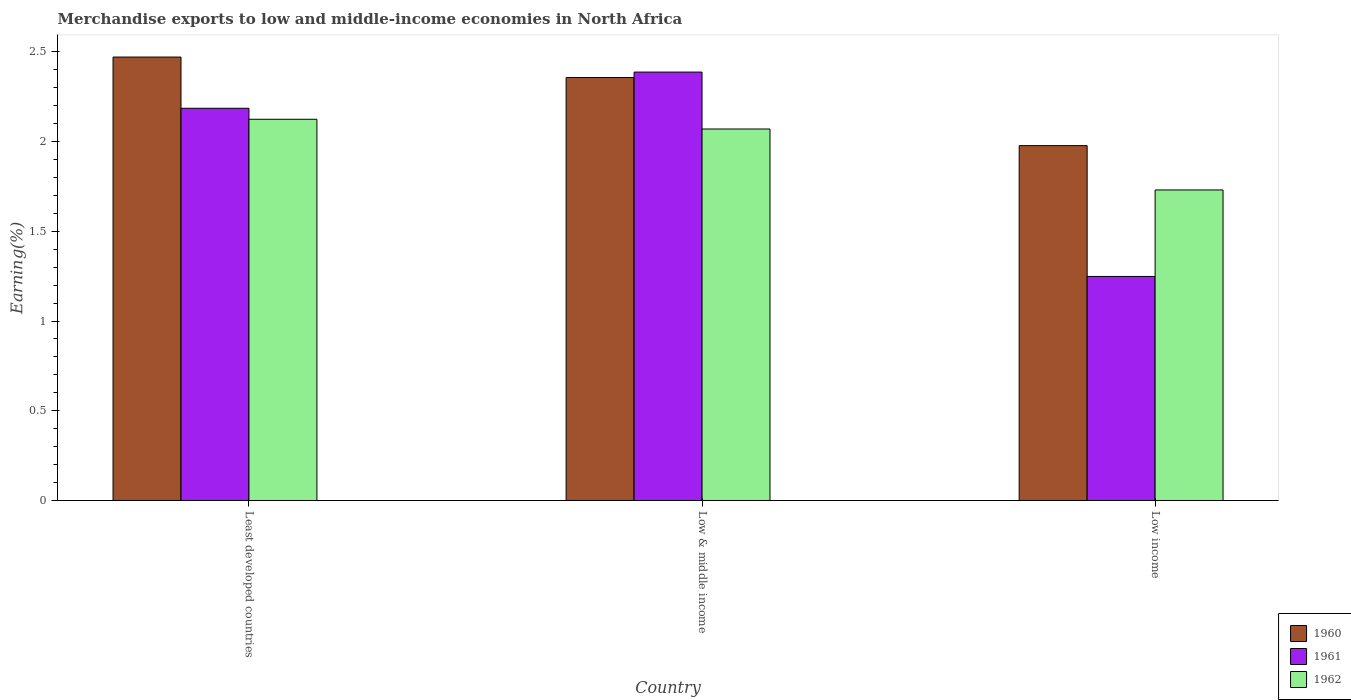How many groups of bars are there?
Your response must be concise. 3. How many bars are there on the 2nd tick from the left?
Keep it short and to the point. 3. How many bars are there on the 2nd tick from the right?
Provide a short and direct response. 3. What is the label of the 1st group of bars from the left?
Your response must be concise. Least developed countries. What is the percentage of amount earned from merchandise exports in 1961 in Low & middle income?
Offer a terse response. 2.39. Across all countries, what is the maximum percentage of amount earned from merchandise exports in 1962?
Make the answer very short. 2.12. Across all countries, what is the minimum percentage of amount earned from merchandise exports in 1962?
Make the answer very short. 1.73. What is the total percentage of amount earned from merchandise exports in 1961 in the graph?
Ensure brevity in your answer.  5.82. What is the difference between the percentage of amount earned from merchandise exports in 1960 in Least developed countries and that in Low income?
Provide a short and direct response. 0.49. What is the difference between the percentage of amount earned from merchandise exports in 1961 in Least developed countries and the percentage of amount earned from merchandise exports in 1960 in Low & middle income?
Make the answer very short. -0.17. What is the average percentage of amount earned from merchandise exports in 1960 per country?
Give a very brief answer. 2.27. What is the difference between the percentage of amount earned from merchandise exports of/in 1962 and percentage of amount earned from merchandise exports of/in 1960 in Low income?
Your response must be concise. -0.25. What is the ratio of the percentage of amount earned from merchandise exports in 1962 in Low & middle income to that in Low income?
Keep it short and to the point. 1.2. Is the percentage of amount earned from merchandise exports in 1961 in Least developed countries less than that in Low & middle income?
Your answer should be very brief. Yes. What is the difference between the highest and the second highest percentage of amount earned from merchandise exports in 1962?
Offer a very short reply. -0.39. What is the difference between the highest and the lowest percentage of amount earned from merchandise exports in 1960?
Your answer should be compact. 0.49. Is the sum of the percentage of amount earned from merchandise exports in 1962 in Least developed countries and Low & middle income greater than the maximum percentage of amount earned from merchandise exports in 1960 across all countries?
Your response must be concise. Yes. How many countries are there in the graph?
Provide a short and direct response. 3. What is the difference between two consecutive major ticks on the Y-axis?
Ensure brevity in your answer.  0.5. Are the values on the major ticks of Y-axis written in scientific E-notation?
Ensure brevity in your answer.  No. Does the graph contain any zero values?
Provide a short and direct response. No. What is the title of the graph?
Offer a very short reply. Merchandise exports to low and middle-income economies in North Africa. What is the label or title of the X-axis?
Your answer should be very brief. Country. What is the label or title of the Y-axis?
Your response must be concise. Earning(%). What is the Earning(%) in 1960 in Least developed countries?
Keep it short and to the point. 2.47. What is the Earning(%) of 1961 in Least developed countries?
Provide a short and direct response. 2.19. What is the Earning(%) of 1962 in Least developed countries?
Provide a short and direct response. 2.12. What is the Earning(%) of 1960 in Low & middle income?
Give a very brief answer. 2.36. What is the Earning(%) in 1961 in Low & middle income?
Ensure brevity in your answer.  2.39. What is the Earning(%) in 1962 in Low & middle income?
Offer a terse response. 2.07. What is the Earning(%) of 1960 in Low income?
Provide a short and direct response. 1.98. What is the Earning(%) of 1961 in Low income?
Offer a terse response. 1.25. What is the Earning(%) in 1962 in Low income?
Make the answer very short. 1.73. Across all countries, what is the maximum Earning(%) in 1960?
Provide a short and direct response. 2.47. Across all countries, what is the maximum Earning(%) in 1961?
Offer a terse response. 2.39. Across all countries, what is the maximum Earning(%) in 1962?
Your response must be concise. 2.12. Across all countries, what is the minimum Earning(%) of 1960?
Provide a short and direct response. 1.98. Across all countries, what is the minimum Earning(%) in 1961?
Your answer should be compact. 1.25. Across all countries, what is the minimum Earning(%) of 1962?
Your response must be concise. 1.73. What is the total Earning(%) in 1960 in the graph?
Make the answer very short. 6.8. What is the total Earning(%) of 1961 in the graph?
Offer a terse response. 5.82. What is the total Earning(%) of 1962 in the graph?
Provide a succinct answer. 5.92. What is the difference between the Earning(%) in 1960 in Least developed countries and that in Low & middle income?
Your answer should be very brief. 0.11. What is the difference between the Earning(%) in 1961 in Least developed countries and that in Low & middle income?
Make the answer very short. -0.2. What is the difference between the Earning(%) in 1962 in Least developed countries and that in Low & middle income?
Make the answer very short. 0.05. What is the difference between the Earning(%) in 1960 in Least developed countries and that in Low income?
Your response must be concise. 0.49. What is the difference between the Earning(%) in 1961 in Least developed countries and that in Low income?
Your response must be concise. 0.94. What is the difference between the Earning(%) of 1962 in Least developed countries and that in Low income?
Give a very brief answer. 0.39. What is the difference between the Earning(%) of 1960 in Low & middle income and that in Low income?
Provide a short and direct response. 0.38. What is the difference between the Earning(%) in 1961 in Low & middle income and that in Low income?
Ensure brevity in your answer.  1.14. What is the difference between the Earning(%) in 1962 in Low & middle income and that in Low income?
Offer a very short reply. 0.34. What is the difference between the Earning(%) of 1960 in Least developed countries and the Earning(%) of 1961 in Low & middle income?
Keep it short and to the point. 0.08. What is the difference between the Earning(%) of 1960 in Least developed countries and the Earning(%) of 1962 in Low & middle income?
Keep it short and to the point. 0.4. What is the difference between the Earning(%) of 1961 in Least developed countries and the Earning(%) of 1962 in Low & middle income?
Keep it short and to the point. 0.12. What is the difference between the Earning(%) of 1960 in Least developed countries and the Earning(%) of 1961 in Low income?
Ensure brevity in your answer.  1.22. What is the difference between the Earning(%) of 1960 in Least developed countries and the Earning(%) of 1962 in Low income?
Offer a very short reply. 0.74. What is the difference between the Earning(%) in 1961 in Least developed countries and the Earning(%) in 1962 in Low income?
Offer a very short reply. 0.46. What is the difference between the Earning(%) of 1960 in Low & middle income and the Earning(%) of 1961 in Low income?
Offer a terse response. 1.11. What is the difference between the Earning(%) of 1960 in Low & middle income and the Earning(%) of 1962 in Low income?
Provide a succinct answer. 0.63. What is the difference between the Earning(%) of 1961 in Low & middle income and the Earning(%) of 1962 in Low income?
Your response must be concise. 0.66. What is the average Earning(%) of 1960 per country?
Give a very brief answer. 2.27. What is the average Earning(%) in 1961 per country?
Keep it short and to the point. 1.94. What is the average Earning(%) in 1962 per country?
Your response must be concise. 1.97. What is the difference between the Earning(%) in 1960 and Earning(%) in 1961 in Least developed countries?
Provide a succinct answer. 0.29. What is the difference between the Earning(%) in 1960 and Earning(%) in 1962 in Least developed countries?
Your response must be concise. 0.35. What is the difference between the Earning(%) in 1961 and Earning(%) in 1962 in Least developed countries?
Ensure brevity in your answer.  0.06. What is the difference between the Earning(%) in 1960 and Earning(%) in 1961 in Low & middle income?
Ensure brevity in your answer.  -0.03. What is the difference between the Earning(%) of 1960 and Earning(%) of 1962 in Low & middle income?
Your response must be concise. 0.29. What is the difference between the Earning(%) of 1961 and Earning(%) of 1962 in Low & middle income?
Your answer should be very brief. 0.32. What is the difference between the Earning(%) in 1960 and Earning(%) in 1961 in Low income?
Your answer should be very brief. 0.73. What is the difference between the Earning(%) of 1960 and Earning(%) of 1962 in Low income?
Your answer should be compact. 0.25. What is the difference between the Earning(%) of 1961 and Earning(%) of 1962 in Low income?
Offer a terse response. -0.48. What is the ratio of the Earning(%) of 1960 in Least developed countries to that in Low & middle income?
Give a very brief answer. 1.05. What is the ratio of the Earning(%) of 1961 in Least developed countries to that in Low & middle income?
Make the answer very short. 0.92. What is the ratio of the Earning(%) in 1962 in Least developed countries to that in Low & middle income?
Give a very brief answer. 1.03. What is the ratio of the Earning(%) of 1960 in Least developed countries to that in Low income?
Keep it short and to the point. 1.25. What is the ratio of the Earning(%) of 1961 in Least developed countries to that in Low income?
Keep it short and to the point. 1.75. What is the ratio of the Earning(%) of 1962 in Least developed countries to that in Low income?
Your answer should be compact. 1.23. What is the ratio of the Earning(%) in 1960 in Low & middle income to that in Low income?
Your response must be concise. 1.19. What is the ratio of the Earning(%) in 1961 in Low & middle income to that in Low income?
Keep it short and to the point. 1.91. What is the ratio of the Earning(%) of 1962 in Low & middle income to that in Low income?
Your answer should be compact. 1.2. What is the difference between the highest and the second highest Earning(%) of 1960?
Your answer should be compact. 0.11. What is the difference between the highest and the second highest Earning(%) in 1961?
Keep it short and to the point. 0.2. What is the difference between the highest and the second highest Earning(%) of 1962?
Give a very brief answer. 0.05. What is the difference between the highest and the lowest Earning(%) of 1960?
Provide a succinct answer. 0.49. What is the difference between the highest and the lowest Earning(%) of 1961?
Your answer should be very brief. 1.14. What is the difference between the highest and the lowest Earning(%) in 1962?
Provide a succinct answer. 0.39. 